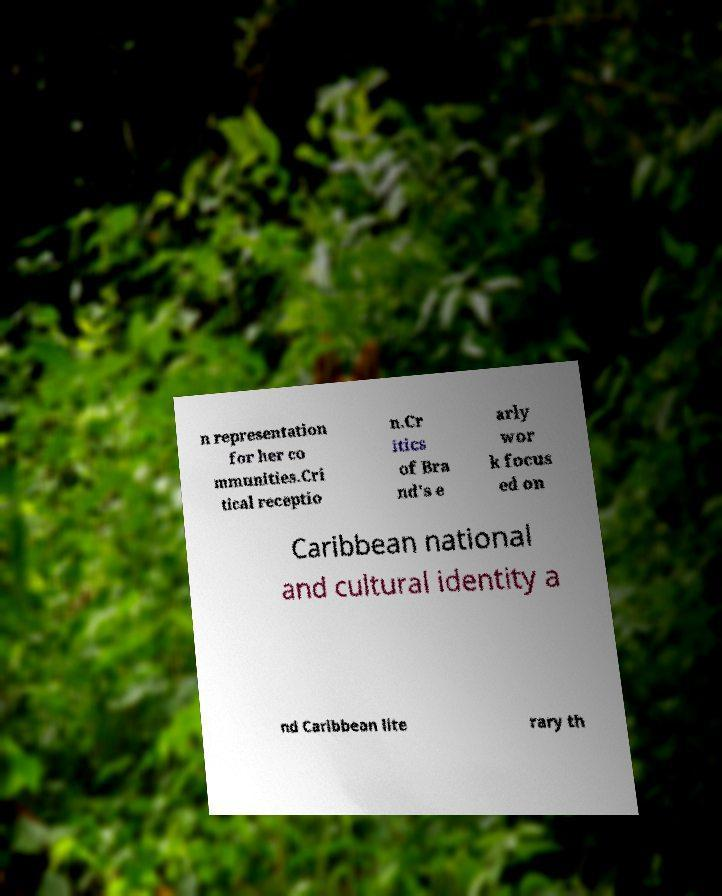What messages or text are displayed in this image? I need them in a readable, typed format. n representation for her co mmunities.Cri tical receptio n.Cr itics of Bra nd's e arly wor k focus ed on Caribbean national and cultural identity a nd Caribbean lite rary th 